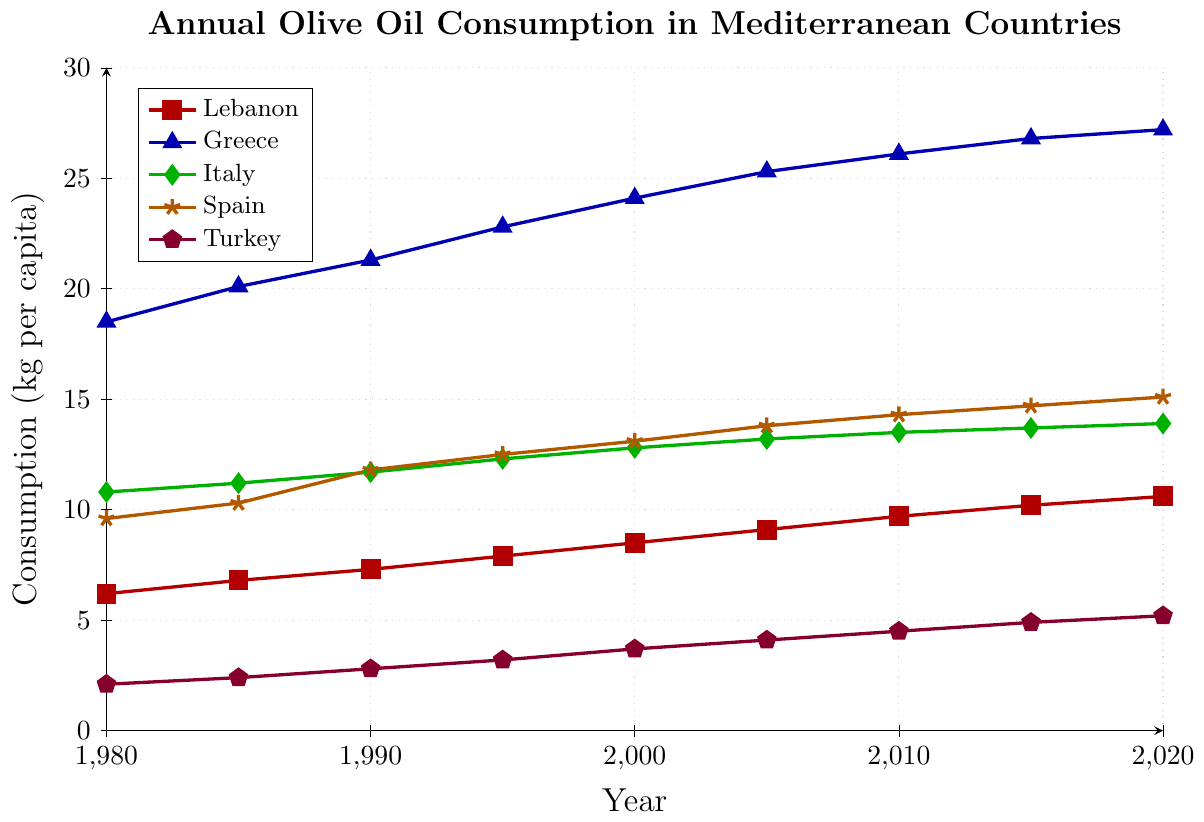What country had the highest olive oil consumption in 1980? According to the figure, Greece had the highest olive oil consumption in 1980 with around 18.5 kg per capita.
Answer: Greece What is the difference in olive oil consumption between Lebanon and Greece in 2020? In the figure, Lebanon had a consumption of 10.6 kg per capita and Greece had 27.2 kg per capita in 2020. Subtracting these gives 27.2 - 10.6 = 16.6 kg per capita.
Answer: 16.6 kg per capita How did the annual olive oil consumption in Spain change from 1980 to 2020? Spain's consumption in 1980 was 9.6 kg per capita and in 2020 it was 15.1 kg per capita. The change is 15.1 - 9.6 = 5.5 kg per capita.
Answer: Increased by 5.5 kg per capita Which country had the lowest olive oil consumption in 2000? In the year 2000, Turkey had the lowest olive oil consumption with 3.7 kg per capita, as indicated by the figure.
Answer: Turkey What is the average olive oil consumption in Italy from 1980 to 2020? The consumption values for Italy are 10.8, 11.2, 11.7, 12.3, 12.8, 13.2, 13.5, 13.7, and 13.9 kg per capita. Summing these values gives 102.1, and dividing by the 9 years gives 102.1 / 9 = 11.34 kg per capita.
Answer: 11.34 kg per capita How does Lebanon's olive oil consumption in 1990 compare to Spain's? In 1990, Lebanon's consumption was 7.3 kg per capita and Spain's was 11.8 kg per capita. Lebanon's consumption was lower.
Answer: Lebanon was lower Which country's olive oil consumption increased the most from 1980 to 2020? By examining the figure, Greece's consumption increased from 18.5 kg to 27.2 kg, Italy from 10.8 kg to 13.9 kg, Spain from 9.6 kg to 15.1 kg, Lebanon from 6.2 kg to 10.6 kg, and Turkey from 2.1 kg to 5.2 kg. Greece had the largest increase of 8.7 kg per capita.
Answer: Greece In which year did Lebanon's olive oil consumption first exceed 10 kg per capita? Referring to the figure, Lebanon's olive oil consumption first exceeded 10 kg per capita in 2015, where it reached 10.2 kg per capita.
Answer: 2015 What are the main trends observed in the olive oil consumption for Turkey from 1980 to 2020? The figure shows that Turkey's olive oil consumption gradually increased from 2.1 kg per capita in 1980 to 5.2 kg per capita in 2020, indicating a consistent upward trend.
Answer: Consistent upward trend Comparing Lebanon and Spain, in which year did Spain's consumption become more than double that of Lebanon's? In 2010, Lebanon's consumption was 9.7 kg per capita and Spain's was 14.3 kg per capita. In 2015, Lebanon's was 10.2 kg per capita and Spain's was 14.7 kg per capita. Therefore, it was in 2010 when Spain’s consumption first became more than double Lebanon's.
Answer: 2010 